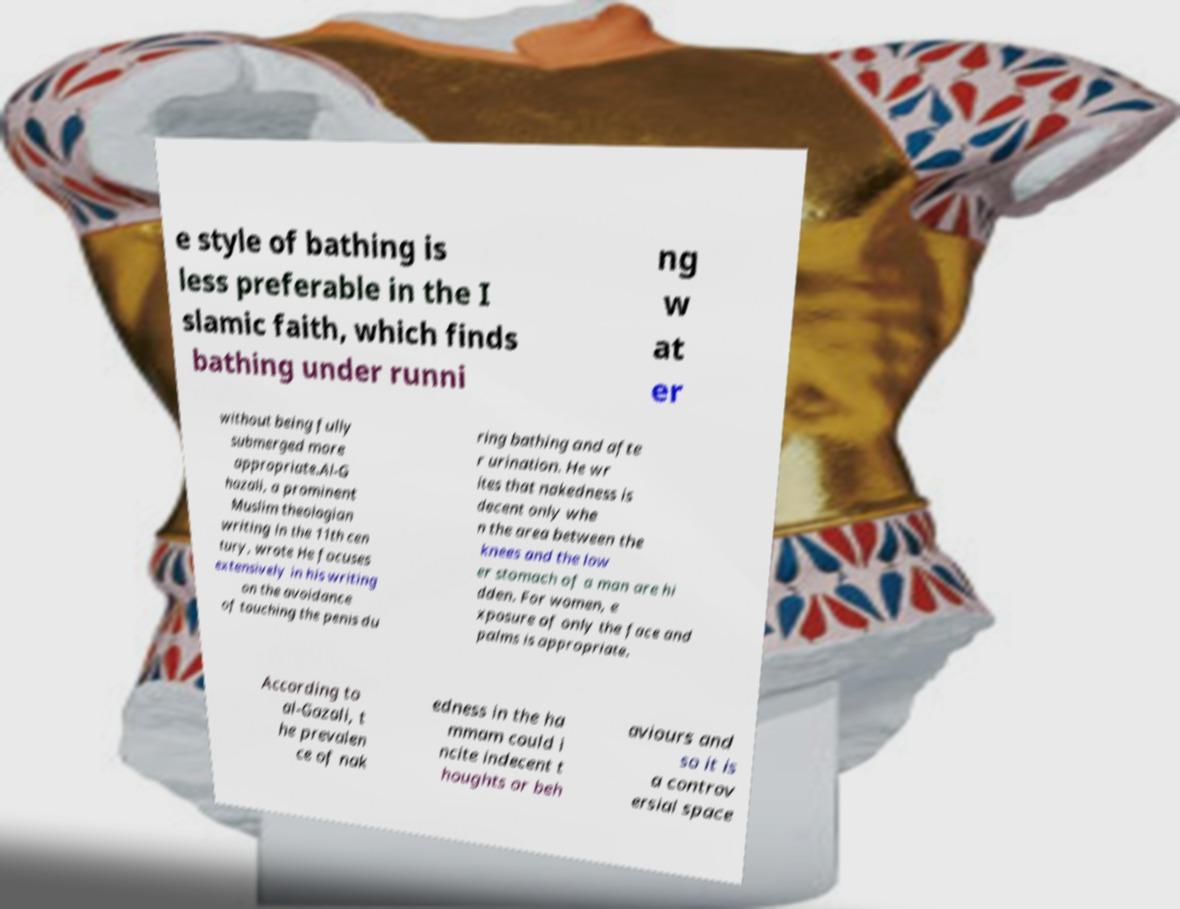There's text embedded in this image that I need extracted. Can you transcribe it verbatim? e style of bathing is less preferable in the I slamic faith, which finds bathing under runni ng w at er without being fully submerged more appropriate.Al-G hazali, a prominent Muslim theologian writing in the 11th cen tury, wrote He focuses extensively in his writing on the avoidance of touching the penis du ring bathing and afte r urination. He wr ites that nakedness is decent only whe n the area between the knees and the low er stomach of a man are hi dden. For women, e xposure of only the face and palms is appropriate. According to al-Gazali, t he prevalen ce of nak edness in the ha mmam could i ncite indecent t houghts or beh aviours and so it is a controv ersial space 